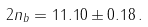<formula> <loc_0><loc_0><loc_500><loc_500>2 n _ { b } = 1 1 . 1 0 \pm 0 . 1 8 \, .</formula> 